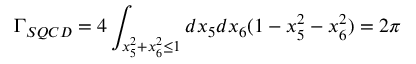Convert formula to latex. <formula><loc_0><loc_0><loc_500><loc_500>\Gamma _ { S Q C D } = 4 \int _ { x _ { 5 } ^ { 2 } + x _ { 6 } ^ { 2 } \leq 1 } d x _ { 5 } d x _ { 6 } ( 1 - x _ { 5 } ^ { 2 } - x _ { 6 } ^ { 2 } ) = 2 \pi</formula> 